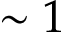<formula> <loc_0><loc_0><loc_500><loc_500>\sim 1</formula> 